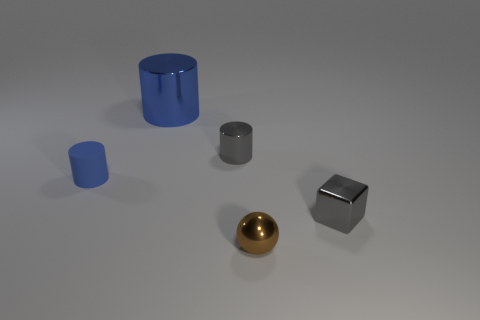Are there any other things that have the same material as the small blue object?
Your response must be concise. No. Are there any brown metallic objects of the same size as the gray metal cube?
Provide a succinct answer. Yes. There is another brown thing that is the same size as the matte thing; what is its material?
Your answer should be very brief. Metal. What shape is the metal thing that is behind the tiny gray metallic cube and in front of the blue shiny cylinder?
Provide a succinct answer. Cylinder. What color is the object that is on the left side of the large shiny cylinder?
Offer a very short reply. Blue. There is a object that is in front of the small blue object and behind the brown sphere; how big is it?
Provide a short and direct response. Small. Are the tiny cube and the small cylinder right of the tiny blue rubber cylinder made of the same material?
Make the answer very short. Yes. What number of other blue metal things have the same shape as the tiny blue object?
Offer a terse response. 1. What material is the tiny cylinder that is the same color as the large cylinder?
Provide a succinct answer. Rubber. What number of yellow things are there?
Offer a very short reply. 0. 